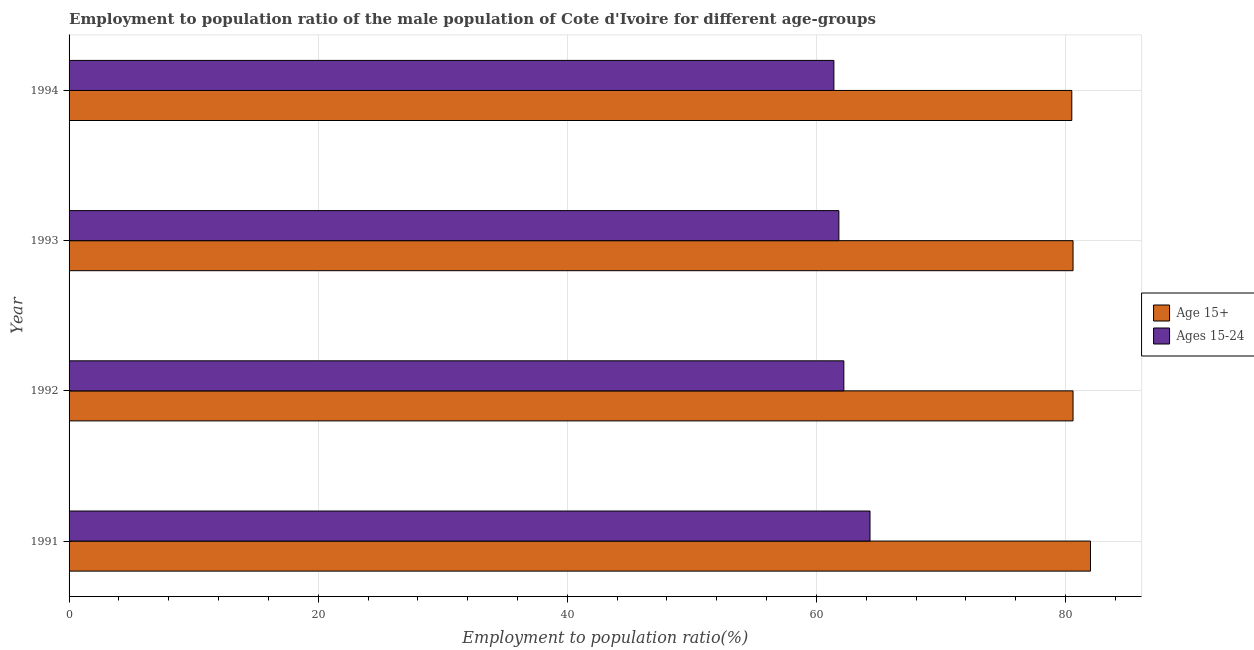How many different coloured bars are there?
Keep it short and to the point. 2. How many groups of bars are there?
Give a very brief answer. 4. Are the number of bars per tick equal to the number of legend labels?
Offer a terse response. Yes. How many bars are there on the 2nd tick from the top?
Your answer should be very brief. 2. What is the label of the 2nd group of bars from the top?
Your answer should be compact. 1993. In how many cases, is the number of bars for a given year not equal to the number of legend labels?
Your response must be concise. 0. What is the employment to population ratio(age 15+) in 1991?
Ensure brevity in your answer.  82. Across all years, what is the minimum employment to population ratio(age 15+)?
Ensure brevity in your answer.  80.5. What is the total employment to population ratio(age 15-24) in the graph?
Offer a very short reply. 249.7. What is the difference between the employment to population ratio(age 15-24) in 1994 and the employment to population ratio(age 15+) in 1993?
Offer a very short reply. -19.2. What is the average employment to population ratio(age 15+) per year?
Your answer should be very brief. 80.92. In the year 1992, what is the difference between the employment to population ratio(age 15-24) and employment to population ratio(age 15+)?
Provide a short and direct response. -18.4. In how many years, is the employment to population ratio(age 15-24) greater than 8 %?
Offer a very short reply. 4. What is the ratio of the employment to population ratio(age 15+) in 1992 to that in 1993?
Offer a terse response. 1. Is the employment to population ratio(age 15+) in 1993 less than that in 1994?
Give a very brief answer. No. What is the difference between the highest and the second highest employment to population ratio(age 15-24)?
Provide a succinct answer. 2.1. Is the sum of the employment to population ratio(age 15-24) in 1992 and 1993 greater than the maximum employment to population ratio(age 15+) across all years?
Keep it short and to the point. Yes. What does the 2nd bar from the top in 1993 represents?
Provide a succinct answer. Age 15+. What does the 2nd bar from the bottom in 1994 represents?
Make the answer very short. Ages 15-24. How many bars are there?
Keep it short and to the point. 8. Are all the bars in the graph horizontal?
Ensure brevity in your answer.  Yes. What is the difference between two consecutive major ticks on the X-axis?
Offer a terse response. 20. Does the graph contain any zero values?
Keep it short and to the point. No. Does the graph contain grids?
Make the answer very short. Yes. Where does the legend appear in the graph?
Your response must be concise. Center right. What is the title of the graph?
Ensure brevity in your answer.  Employment to population ratio of the male population of Cote d'Ivoire for different age-groups. What is the label or title of the X-axis?
Keep it short and to the point. Employment to population ratio(%). What is the label or title of the Y-axis?
Provide a short and direct response. Year. What is the Employment to population ratio(%) of Age 15+ in 1991?
Give a very brief answer. 82. What is the Employment to population ratio(%) in Ages 15-24 in 1991?
Make the answer very short. 64.3. What is the Employment to population ratio(%) of Age 15+ in 1992?
Provide a succinct answer. 80.6. What is the Employment to population ratio(%) of Ages 15-24 in 1992?
Offer a terse response. 62.2. What is the Employment to population ratio(%) in Age 15+ in 1993?
Keep it short and to the point. 80.6. What is the Employment to population ratio(%) of Ages 15-24 in 1993?
Give a very brief answer. 61.8. What is the Employment to population ratio(%) in Age 15+ in 1994?
Give a very brief answer. 80.5. What is the Employment to population ratio(%) of Ages 15-24 in 1994?
Offer a terse response. 61.4. Across all years, what is the maximum Employment to population ratio(%) in Ages 15-24?
Keep it short and to the point. 64.3. Across all years, what is the minimum Employment to population ratio(%) in Age 15+?
Your answer should be very brief. 80.5. Across all years, what is the minimum Employment to population ratio(%) in Ages 15-24?
Provide a succinct answer. 61.4. What is the total Employment to population ratio(%) of Age 15+ in the graph?
Your answer should be compact. 323.7. What is the total Employment to population ratio(%) in Ages 15-24 in the graph?
Keep it short and to the point. 249.7. What is the difference between the Employment to population ratio(%) in Age 15+ in 1991 and that in 1992?
Your answer should be very brief. 1.4. What is the difference between the Employment to population ratio(%) in Ages 15-24 in 1991 and that in 1992?
Keep it short and to the point. 2.1. What is the difference between the Employment to population ratio(%) in Age 15+ in 1991 and that in 1993?
Give a very brief answer. 1.4. What is the difference between the Employment to population ratio(%) in Ages 15-24 in 1991 and that in 1993?
Your answer should be compact. 2.5. What is the difference between the Employment to population ratio(%) of Age 15+ in 1992 and that in 1994?
Your response must be concise. 0.1. What is the difference between the Employment to population ratio(%) of Age 15+ in 1993 and that in 1994?
Keep it short and to the point. 0.1. What is the difference between the Employment to population ratio(%) in Age 15+ in 1991 and the Employment to population ratio(%) in Ages 15-24 in 1992?
Provide a short and direct response. 19.8. What is the difference between the Employment to population ratio(%) in Age 15+ in 1991 and the Employment to population ratio(%) in Ages 15-24 in 1993?
Make the answer very short. 20.2. What is the difference between the Employment to population ratio(%) in Age 15+ in 1991 and the Employment to population ratio(%) in Ages 15-24 in 1994?
Your answer should be compact. 20.6. What is the difference between the Employment to population ratio(%) in Age 15+ in 1992 and the Employment to population ratio(%) in Ages 15-24 in 1993?
Make the answer very short. 18.8. What is the difference between the Employment to population ratio(%) of Age 15+ in 1992 and the Employment to population ratio(%) of Ages 15-24 in 1994?
Your answer should be very brief. 19.2. What is the average Employment to population ratio(%) of Age 15+ per year?
Provide a short and direct response. 80.92. What is the average Employment to population ratio(%) of Ages 15-24 per year?
Offer a terse response. 62.42. In the year 1991, what is the difference between the Employment to population ratio(%) in Age 15+ and Employment to population ratio(%) in Ages 15-24?
Provide a succinct answer. 17.7. In the year 1992, what is the difference between the Employment to population ratio(%) of Age 15+ and Employment to population ratio(%) of Ages 15-24?
Offer a very short reply. 18.4. In the year 1993, what is the difference between the Employment to population ratio(%) in Age 15+ and Employment to population ratio(%) in Ages 15-24?
Your response must be concise. 18.8. In the year 1994, what is the difference between the Employment to population ratio(%) in Age 15+ and Employment to population ratio(%) in Ages 15-24?
Your answer should be very brief. 19.1. What is the ratio of the Employment to population ratio(%) of Age 15+ in 1991 to that in 1992?
Give a very brief answer. 1.02. What is the ratio of the Employment to population ratio(%) of Ages 15-24 in 1991 to that in 1992?
Your answer should be compact. 1.03. What is the ratio of the Employment to population ratio(%) in Age 15+ in 1991 to that in 1993?
Make the answer very short. 1.02. What is the ratio of the Employment to population ratio(%) of Ages 15-24 in 1991 to that in 1993?
Offer a very short reply. 1.04. What is the ratio of the Employment to population ratio(%) in Age 15+ in 1991 to that in 1994?
Your response must be concise. 1.02. What is the ratio of the Employment to population ratio(%) in Ages 15-24 in 1991 to that in 1994?
Offer a terse response. 1.05. What is the ratio of the Employment to population ratio(%) of Ages 15-24 in 1992 to that in 1993?
Make the answer very short. 1.01. What is the ratio of the Employment to population ratio(%) in Age 15+ in 1992 to that in 1994?
Offer a terse response. 1. What is the ratio of the Employment to population ratio(%) of Ages 15-24 in 1992 to that in 1994?
Offer a terse response. 1.01. What is the difference between the highest and the second highest Employment to population ratio(%) of Age 15+?
Provide a succinct answer. 1.4. What is the difference between the highest and the lowest Employment to population ratio(%) in Age 15+?
Your answer should be very brief. 1.5. What is the difference between the highest and the lowest Employment to population ratio(%) of Ages 15-24?
Provide a succinct answer. 2.9. 